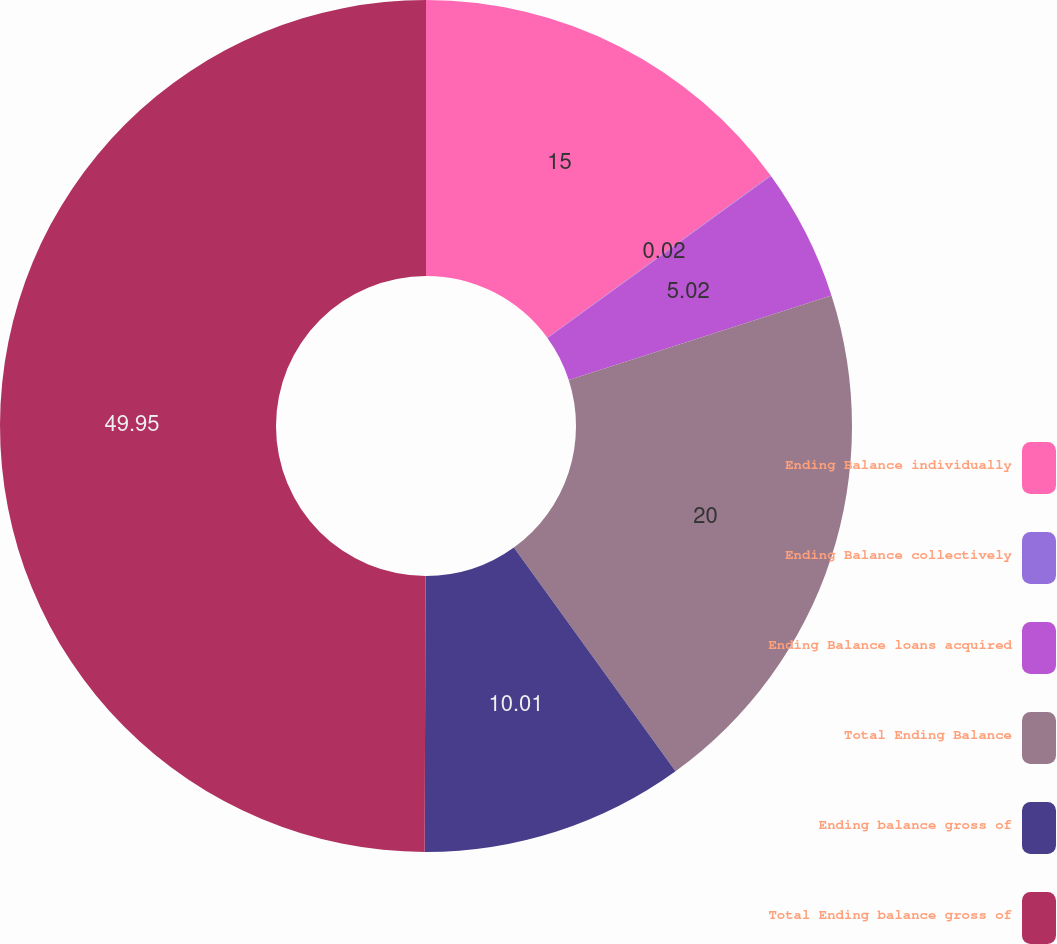<chart> <loc_0><loc_0><loc_500><loc_500><pie_chart><fcel>Ending Balance individually<fcel>Ending Balance collectively<fcel>Ending Balance loans acquired<fcel>Total Ending Balance<fcel>Ending balance gross of<fcel>Total Ending balance gross of<nl><fcel>15.0%<fcel>0.02%<fcel>5.02%<fcel>20.0%<fcel>10.01%<fcel>49.95%<nl></chart> 